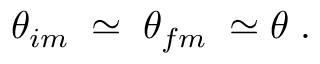<formula> <loc_0><loc_0><loc_500><loc_500>{ \theta } _ { i m } \, \simeq \, { \theta } _ { f m } \, \simeq \theta \, .</formula> 